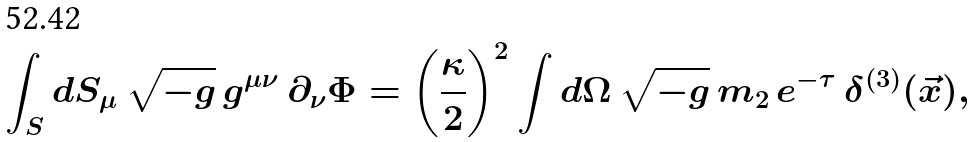Convert formula to latex. <formula><loc_0><loc_0><loc_500><loc_500>\int _ { S } d S _ { \mu } \, \sqrt { - g } \, g ^ { \mu \nu } \, \partial _ { \nu } \Phi = \left ( \frac { \kappa } { 2 } \right ) ^ { 2 } \int d \Omega \, \sqrt { - g } \, m _ { 2 } \, e ^ { - \tau } \, \delta ^ { ( 3 ) } ( \vec { x } ) ,</formula> 